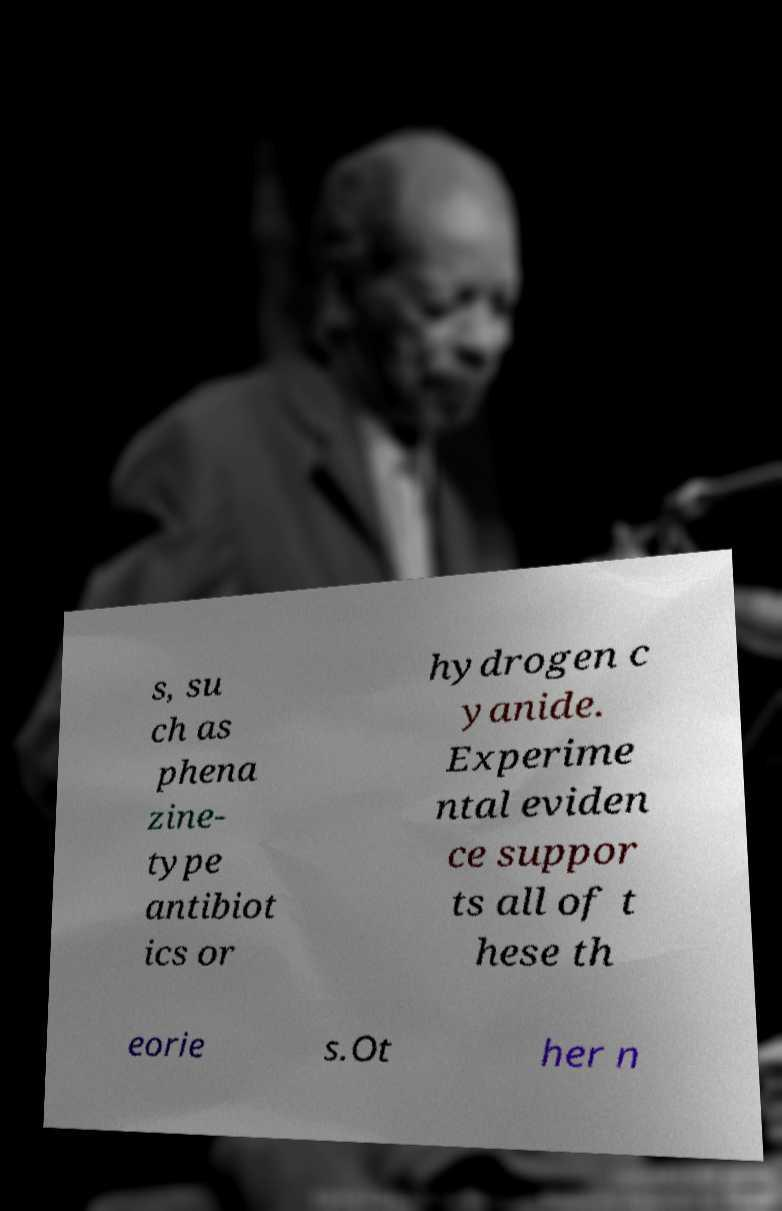I need the written content from this picture converted into text. Can you do that? s, su ch as phena zine- type antibiot ics or hydrogen c yanide. Experime ntal eviden ce suppor ts all of t hese th eorie s.Ot her n 